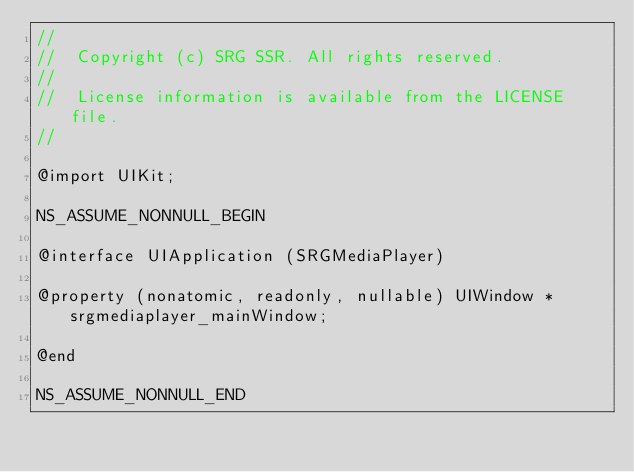<code> <loc_0><loc_0><loc_500><loc_500><_C_>//
//  Copyright (c) SRG SSR. All rights reserved.
//
//  License information is available from the LICENSE file.
//

@import UIKit;

NS_ASSUME_NONNULL_BEGIN

@interface UIApplication (SRGMediaPlayer)

@property (nonatomic, readonly, nullable) UIWindow *srgmediaplayer_mainWindow;

@end

NS_ASSUME_NONNULL_END
</code> 